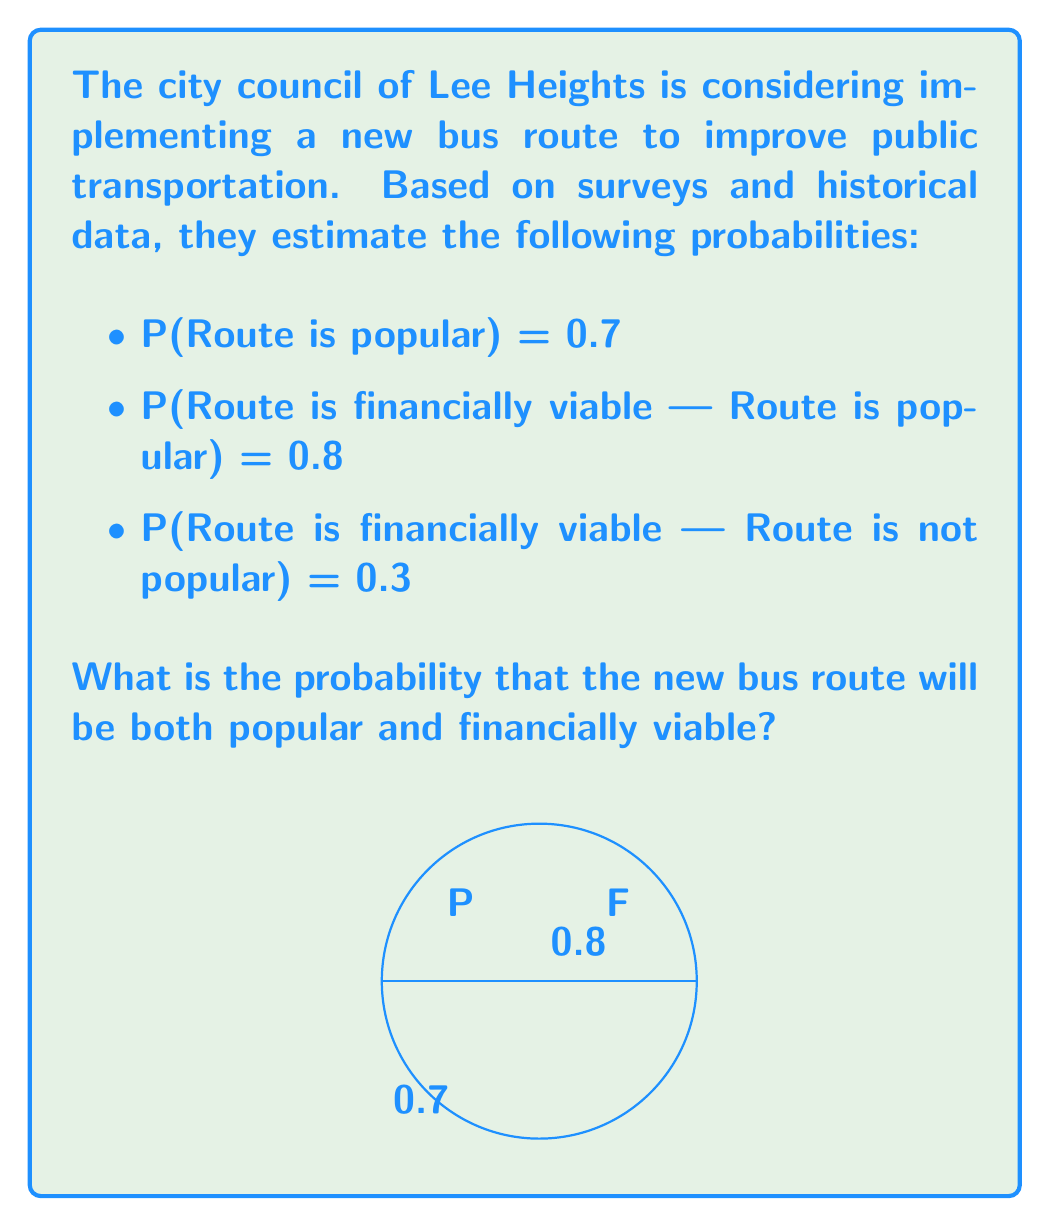Help me with this question. To solve this problem, we'll use the multiplication rule of probability. We need to find P(Route is popular AND Route is financially viable).

Step 1: Identify the given probabilities
- Let P = Event that the route is popular
- Let F = Event that the route is financially viable
- P(P) = 0.7
- P(F|P) = 0.8 (probability of F given P)

Step 2: Apply the multiplication rule
The probability of both events occurring is:

$$P(P \cap F) = P(P) \cdot P(F|P)$$

Step 3: Substitute the values
$$P(P \cap F) = 0.7 \cdot 0.8$$

Step 4: Calculate the result
$$P(P \cap F) = 0.56$$

Therefore, the probability that the new bus route will be both popular and financially viable is 0.56 or 56%.
Answer: 0.56 